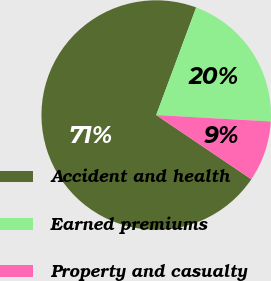Convert chart. <chart><loc_0><loc_0><loc_500><loc_500><pie_chart><fcel>Accident and health<fcel>Earned premiums<fcel>Property and casualty<nl><fcel>71.21%<fcel>20.23%<fcel>8.56%<nl></chart> 